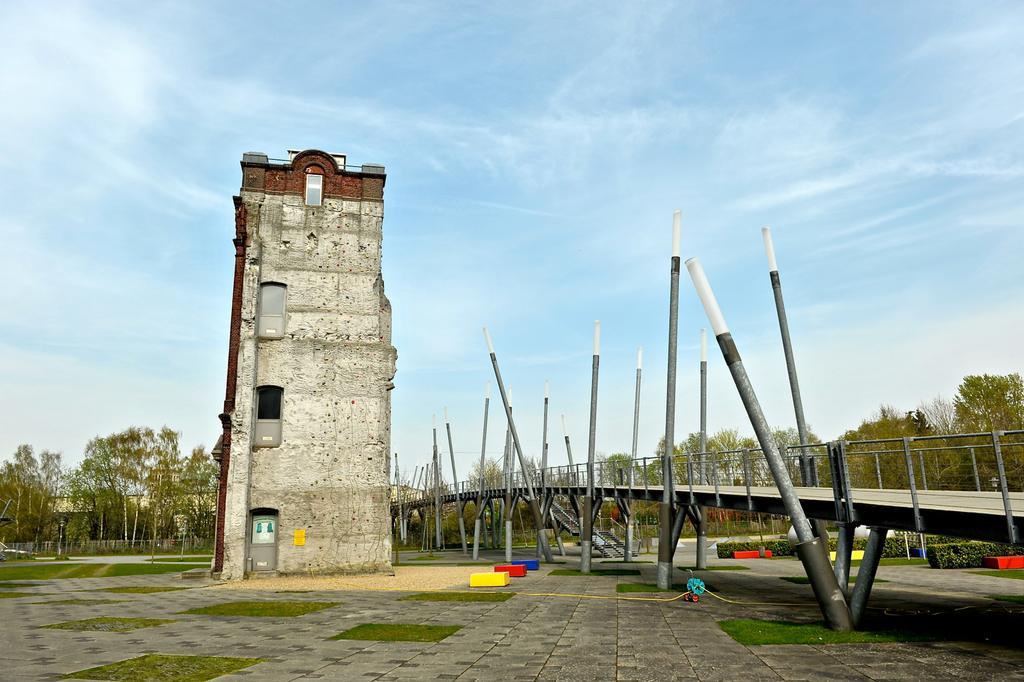Please provide a concise description of this image. In front of the image there is a tower, beside the tower there is a bridge, in the background of the image there are trees and buildings. 